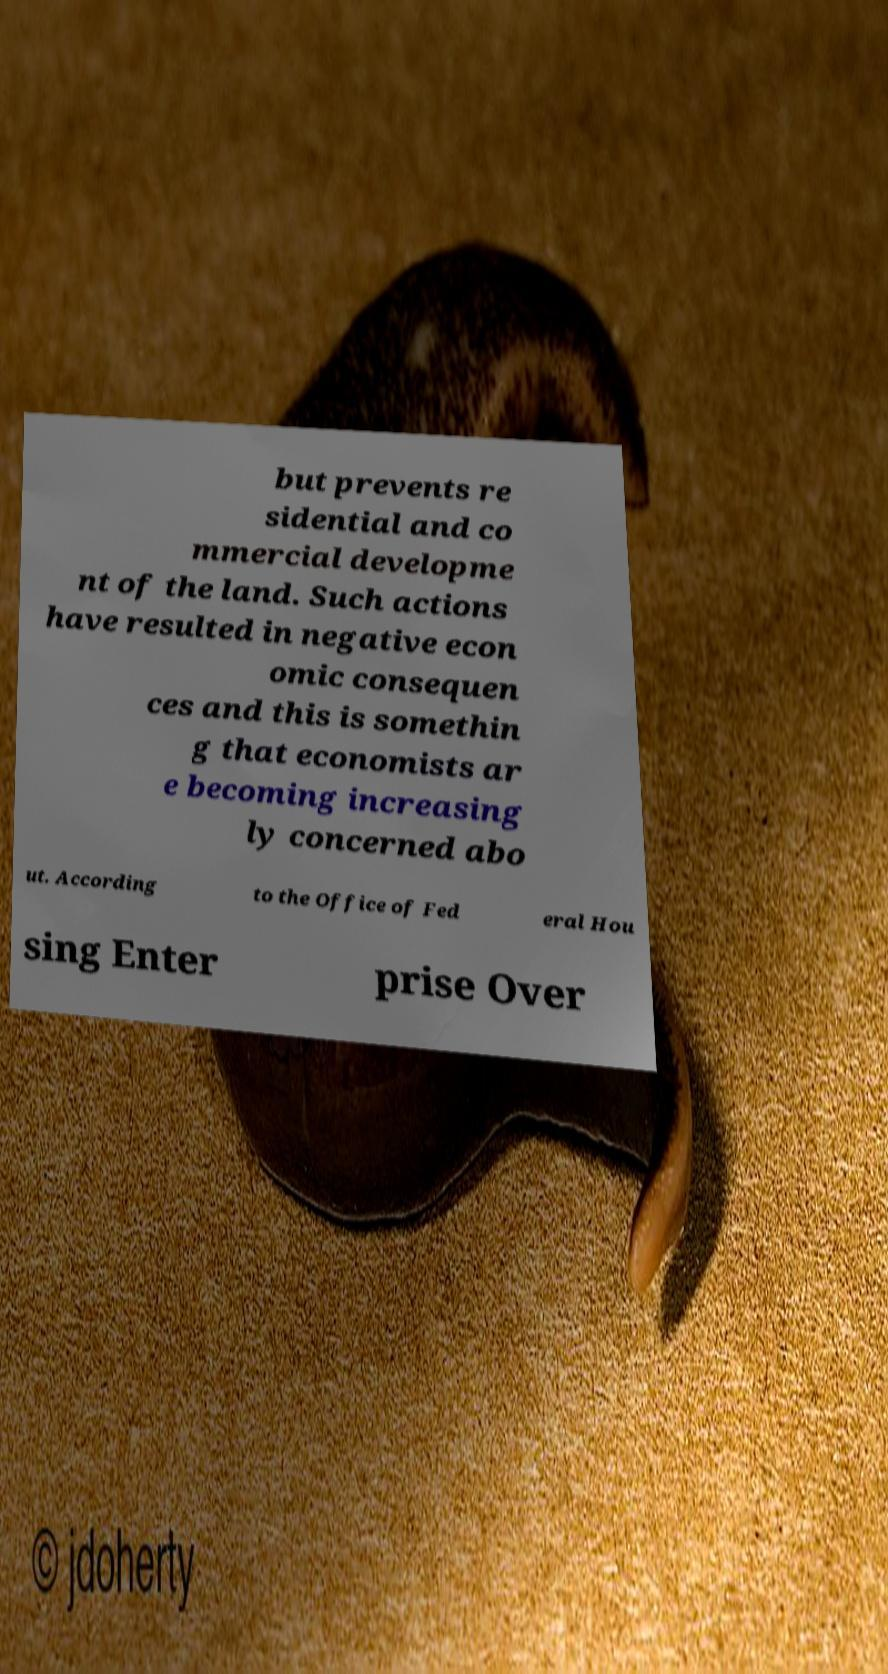Can you accurately transcribe the text from the provided image for me? but prevents re sidential and co mmercial developme nt of the land. Such actions have resulted in negative econ omic consequen ces and this is somethin g that economists ar e becoming increasing ly concerned abo ut. According to the Office of Fed eral Hou sing Enter prise Over 